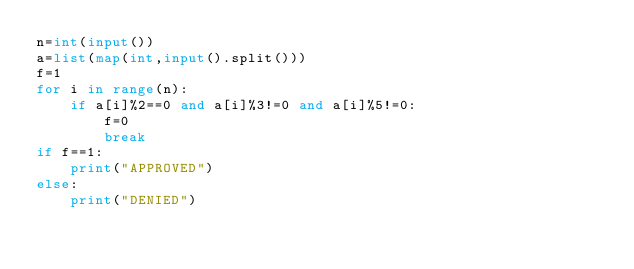Convert code to text. <code><loc_0><loc_0><loc_500><loc_500><_Python_>n=int(input())
a=list(map(int,input().split()))
f=1
for i in range(n):
    if a[i]%2==0 and a[i]%3!=0 and a[i]%5!=0:
        f=0
        break
if f==1:
    print("APPROVED")
else:
    print("DENIED")</code> 